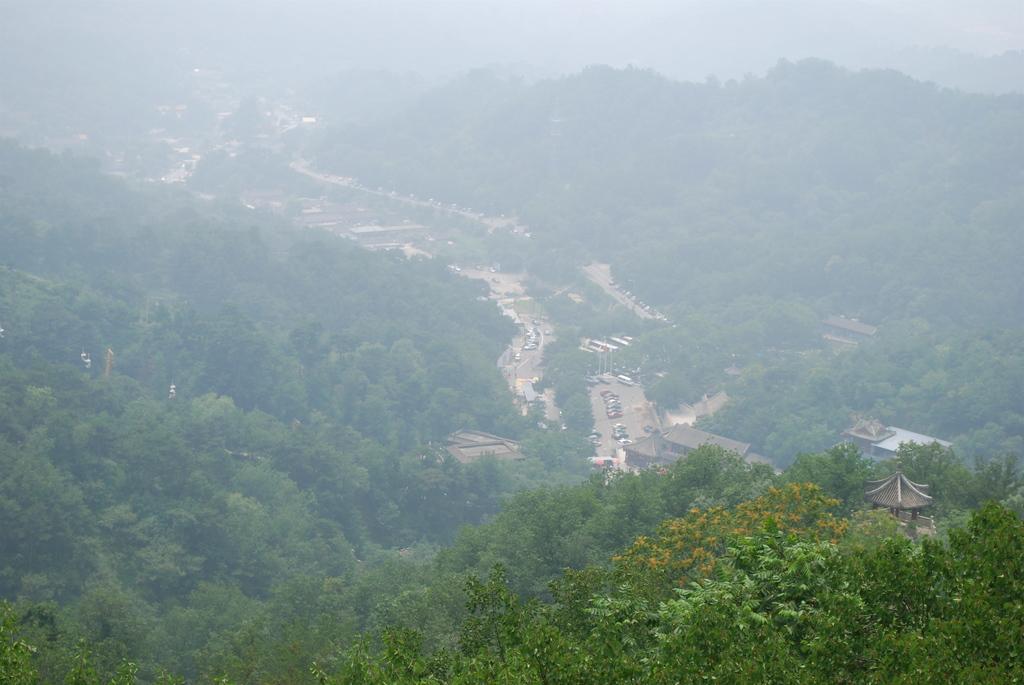Could you give a brief overview of what you see in this image? Here in this picture we can see an Aerial view of a place and we can see most of the place is covered with trees over there and we can see houses present and we can see vehicles present on the road over there. 